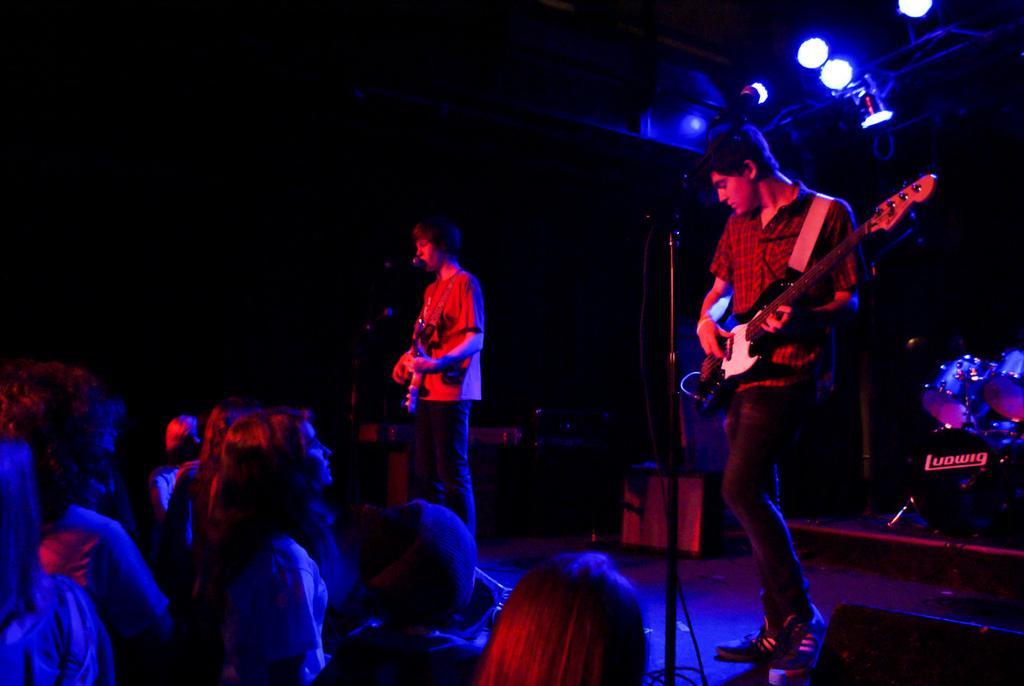In one or two sentences, can you explain what this image depicts? There are two people standing and playing guitars. this is the mic attached to the mike stand. I can see a person signing a song. These are the people watching their performance. At the right side of the image I can see drums. These are the show lights at the top. 